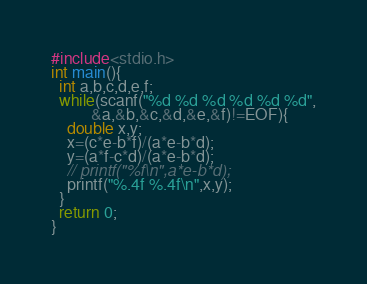<code> <loc_0><loc_0><loc_500><loc_500><_C_>#include<stdio.h>
int main(){
  int a,b,c,d,e,f;
  while(scanf("%d %d %d %d %d %d",
	      &a,&b,&c,&d,&e,&f)!=EOF){
    double x,y;
    x=(c*e-b*f)/(a*e-b*d);
    y=(a*f-c*d)/(a*e-b*d);
    // printf("%f\n",a*e-b*d);
    printf("%.4f %.4f\n",x,y);
  }
  return 0;
}</code> 